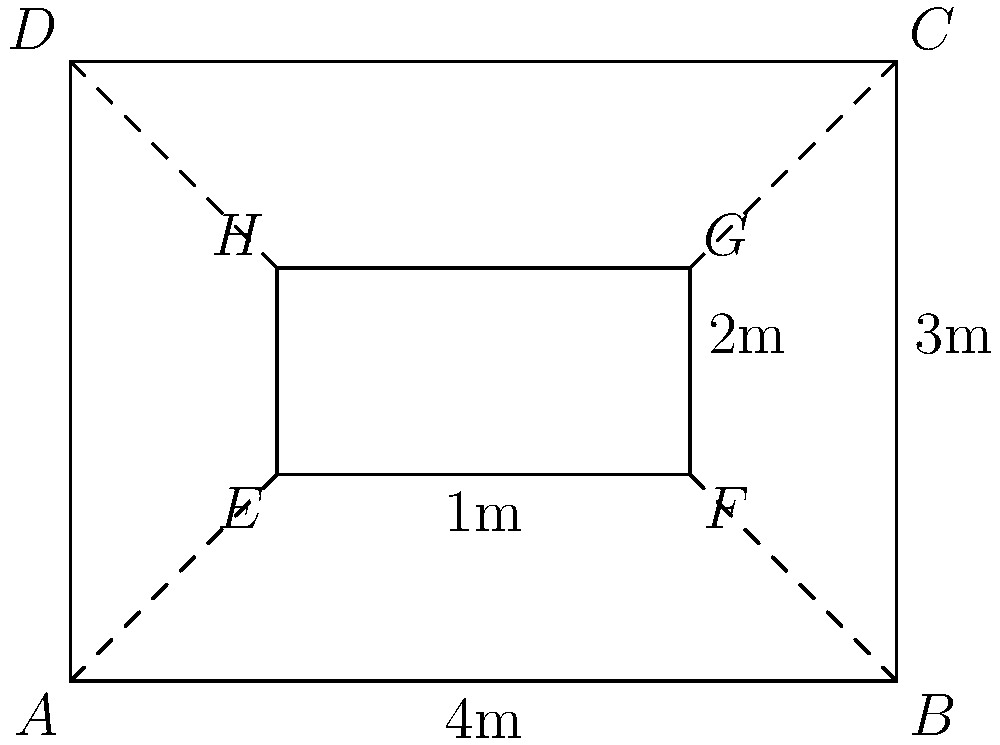In an exhibition room with dimensions 4m x 3m, a laser grid system needs to be installed to protect valuable artworks. The security consultant suggests creating a smaller grid (EFGH) within the room (ABCD) for optimal coverage. If the smaller grid is positioned 1m from each wall, what is the ratio of the area covered by the laser grid to the total room area? To solve this problem, let's follow these steps:

1. Calculate the area of the entire room (ABCD):
   Area of ABCD = 4m × 3m = 12 m²

2. Calculate the area of the smaller grid (EFGH):
   Length of EF = 4m - 2m = 2m
   Width of EH = 3m - 2m = 1m
   Area of EFGH = 2m × 1m = 2 m²

3. Calculate the ratio of the laser grid area to the total room area:
   Ratio = Area of EFGH : Area of ABCD
   Ratio = 2 : 12

4. Simplify the ratio:
   Ratio = 1 : 6

Therefore, the ratio of the area covered by the laser grid to the total room area is 1:6.
Answer: 1:6 